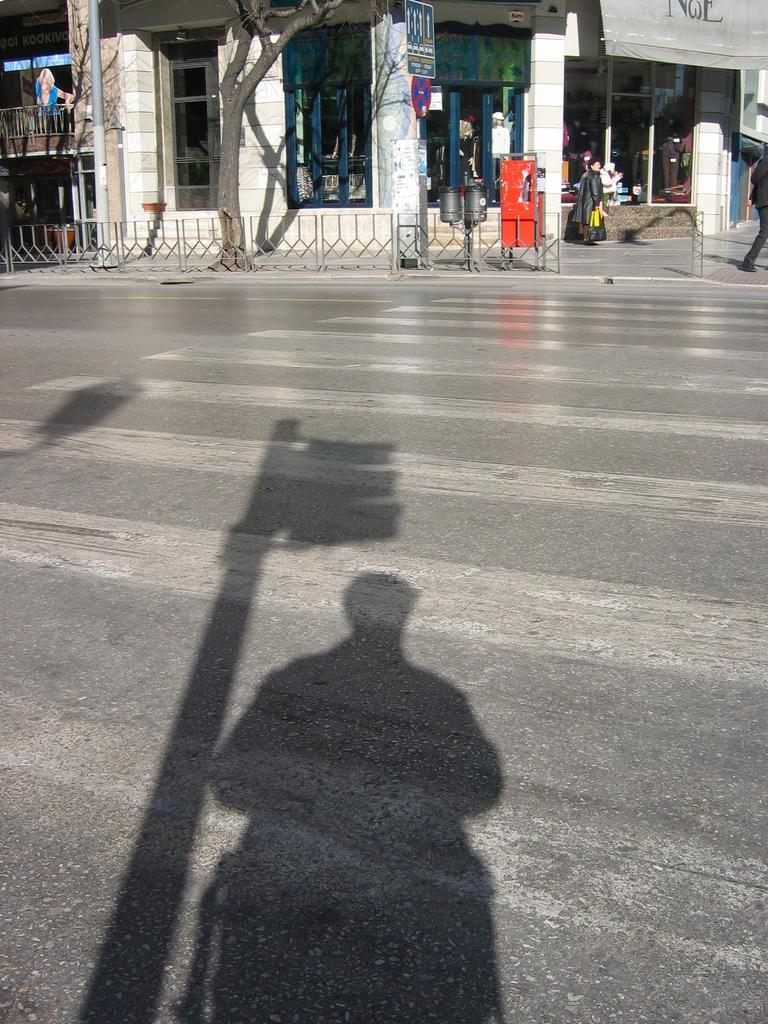What can be seen on the ground in the foreground of the image? There are shadows on the road in the foreground. What type of natural element is present in the image? There is a tree in the image. What separates or defines a space in the image? There is a boundary in the image. Can you describe the people in the image? There are people in the image, but their specific actions or appearances are not mentioned in the facts. What type of commercial or social activity might be taking place in the image? It appears there are stalls in the image, which suggests a market or similar gathering. What is a vertical structure present in the image? There is a pole in the image. What architectural feature can be seen in the image? There are pillars in the image. What other objects are visible at the top side of the image? The facts mention that there are other objects at the top side of the image, but their specific nature is not described. Where is the desk located in the image? There is no desk present in the image. What type of farming equipment can be seen in the image? There is no farming equipment, such as a plough, present in the image. 